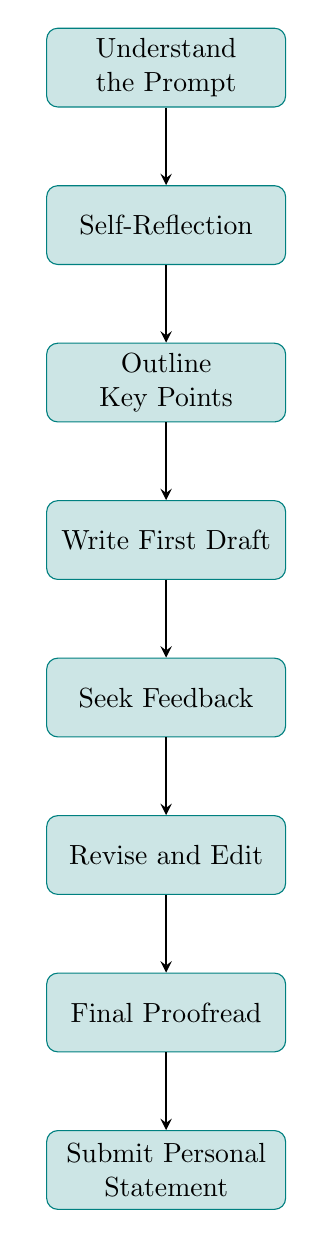What is the first step in the process? The first node in the flow chart represents the initial action that should be taken, which is "Understand the Prompt".
Answer: Understand the Prompt How many nodes are present in the diagram? To find the answer, we count each unique step represented by the nodes in the flow chart. There are a total of 8 nodes listed.
Answer: 8 What does the fourth step involve? The fourth node in the flow chart is "Write First Draft", indicating that this is the task to be completed at this point in the process.
Answer: Write First Draft What is the last action to take according to the diagram? The final node in the flow chart indicates the last action in the process, which is "Submit Personal Statement".
Answer: Submit Personal Statement Which step comes after the "Seek Feedback"? To answer this, we look at the flow connections to find the node that directly follows "Seek Feedback", which is the "Revise and Edit" node.
Answer: Revise and Edit What do you do after "Self-Reflection"? According to the flow chart, the action following "Self-Reflection" is outlined in the next node, which is "Outline Key Points".
Answer: Outline Key Points Which two steps are directly connected? By examining the connections between nodes, we can identify that "Revise and Edit" is directly connected to "Seek Feedback".
Answer: Revise and Edit, Seek Feedback What is the primary purpose of the "Final Proofread"? The context of this node suggests that its purpose is to ensure the personal statement is finalized, catching any remaining mistakes or ensuring polish before submission.
Answer: Ensure statement is polished 